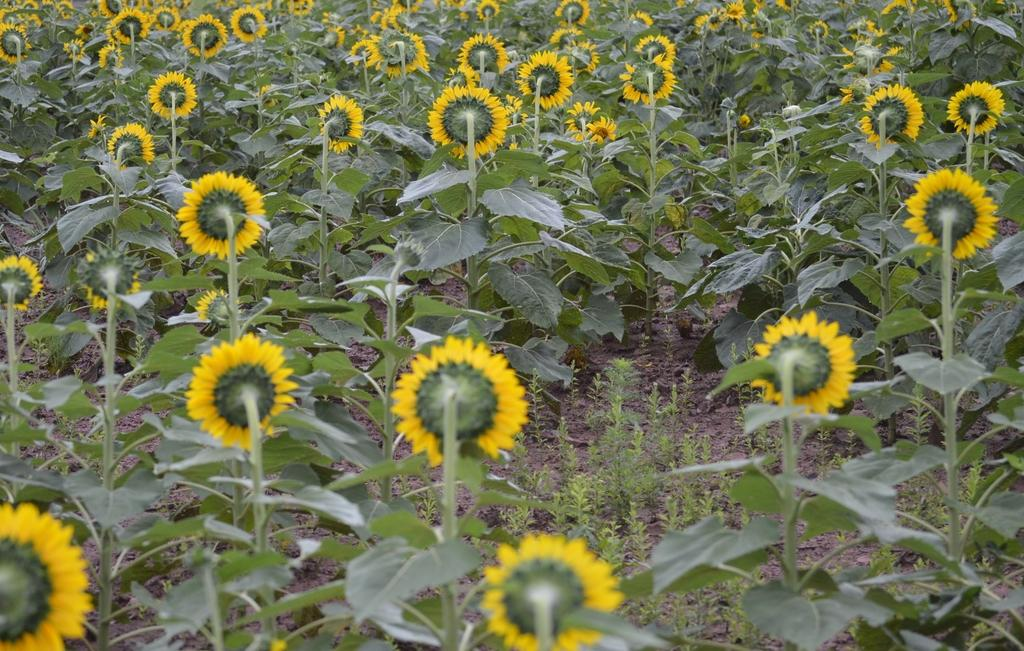What type of living organisms can be seen in the image? Plants can be seen in the image. What specific feature of the plants can be observed in the image? There are yellow color flowers in the image. What type of crime is being committed in the image? There is no crime present in the image; it features plants with yellow flowers. What effect does the presence of the plants have on the cats in the image? There are no cats present in the image, so it is not possible to determine any effect on them. 